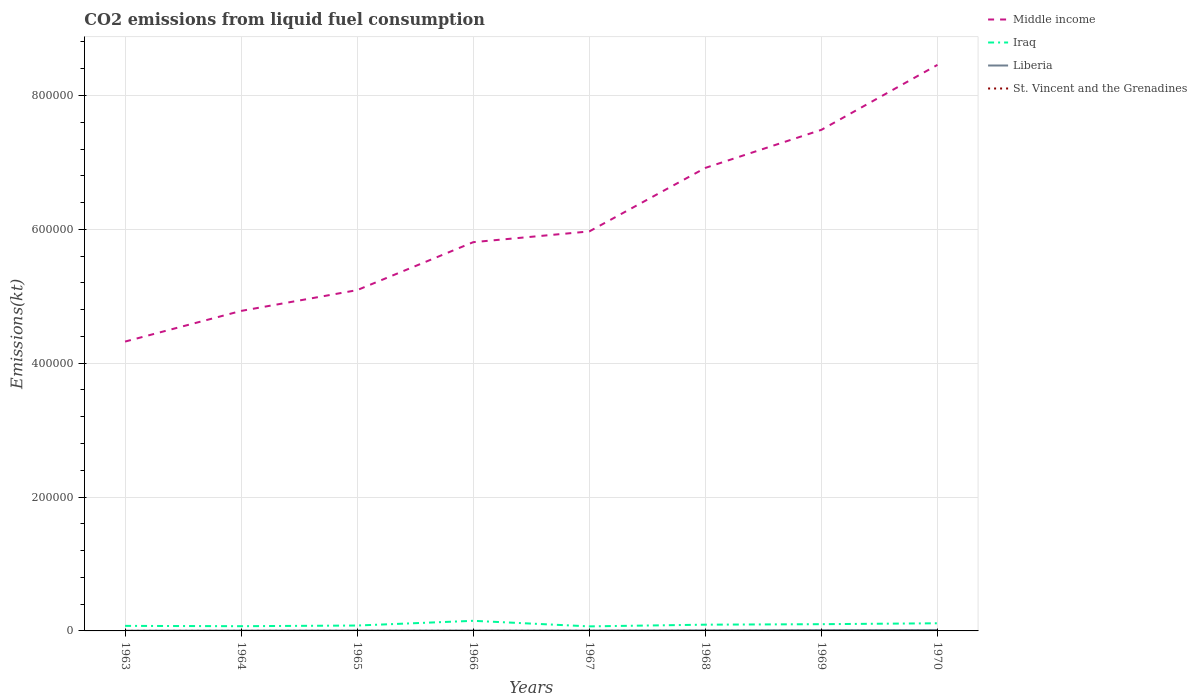Does the line corresponding to Liberia intersect with the line corresponding to St. Vincent and the Grenadines?
Provide a short and direct response. No. Is the number of lines equal to the number of legend labels?
Your answer should be very brief. Yes. Across all years, what is the maximum amount of CO2 emitted in Middle income?
Provide a succinct answer. 4.32e+05. In which year was the amount of CO2 emitted in St. Vincent and the Grenadines maximum?
Your answer should be very brief. 1963. What is the total amount of CO2 emitted in Liberia in the graph?
Provide a short and direct response. -245.69. What is the difference between the highest and the second highest amount of CO2 emitted in Liberia?
Offer a terse response. 1052.43. What is the difference between the highest and the lowest amount of CO2 emitted in St. Vincent and the Grenadines?
Your response must be concise. 3. Is the amount of CO2 emitted in St. Vincent and the Grenadines strictly greater than the amount of CO2 emitted in Middle income over the years?
Offer a terse response. Yes. How many years are there in the graph?
Offer a terse response. 8. What is the difference between two consecutive major ticks on the Y-axis?
Your answer should be very brief. 2.00e+05. Does the graph contain any zero values?
Provide a short and direct response. No. Does the graph contain grids?
Your response must be concise. Yes. Where does the legend appear in the graph?
Make the answer very short. Top right. How are the legend labels stacked?
Offer a terse response. Vertical. What is the title of the graph?
Make the answer very short. CO2 emissions from liquid fuel consumption. What is the label or title of the X-axis?
Your answer should be very brief. Years. What is the label or title of the Y-axis?
Keep it short and to the point. Emissions(kt). What is the Emissions(kt) of Middle income in 1963?
Make the answer very short. 4.32e+05. What is the Emissions(kt) in Iraq in 1963?
Provide a short and direct response. 7528.35. What is the Emissions(kt) in Liberia in 1963?
Offer a terse response. 355.7. What is the Emissions(kt) of St. Vincent and the Grenadines in 1963?
Ensure brevity in your answer.  14.67. What is the Emissions(kt) in Middle income in 1964?
Provide a succinct answer. 4.78e+05. What is the Emissions(kt) in Iraq in 1964?
Offer a very short reply. 7066.31. What is the Emissions(kt) of Liberia in 1964?
Keep it short and to the point. 484.04. What is the Emissions(kt) of St. Vincent and the Grenadines in 1964?
Offer a terse response. 18.34. What is the Emissions(kt) in Middle income in 1965?
Offer a terse response. 5.09e+05. What is the Emissions(kt) in Iraq in 1965?
Give a very brief answer. 8052.73. What is the Emissions(kt) in Liberia in 1965?
Ensure brevity in your answer.  557.38. What is the Emissions(kt) in St. Vincent and the Grenadines in 1965?
Your answer should be very brief. 14.67. What is the Emissions(kt) of Middle income in 1966?
Your response must be concise. 5.81e+05. What is the Emissions(kt) of Iraq in 1966?
Ensure brevity in your answer.  1.51e+04. What is the Emissions(kt) in Liberia in 1966?
Your response must be concise. 612.39. What is the Emissions(kt) in St. Vincent and the Grenadines in 1966?
Provide a short and direct response. 18.34. What is the Emissions(kt) of Middle income in 1967?
Provide a succinct answer. 5.97e+05. What is the Emissions(kt) of Iraq in 1967?
Offer a terse response. 6787.62. What is the Emissions(kt) in Liberia in 1967?
Give a very brief answer. 612.39. What is the Emissions(kt) of St. Vincent and the Grenadines in 1967?
Your answer should be compact. 18.34. What is the Emissions(kt) in Middle income in 1968?
Give a very brief answer. 6.92e+05. What is the Emissions(kt) in Iraq in 1968?
Provide a succinct answer. 9343.52. What is the Emissions(kt) of Liberia in 1968?
Offer a terse response. 858.08. What is the Emissions(kt) in St. Vincent and the Grenadines in 1968?
Your response must be concise. 22. What is the Emissions(kt) of Middle income in 1969?
Keep it short and to the point. 7.49e+05. What is the Emissions(kt) of Iraq in 1969?
Ensure brevity in your answer.  1.01e+04. What is the Emissions(kt) of Liberia in 1969?
Your answer should be very brief. 1235.78. What is the Emissions(kt) of St. Vincent and the Grenadines in 1969?
Make the answer very short. 29.34. What is the Emissions(kt) in Middle income in 1970?
Offer a very short reply. 8.46e+05. What is the Emissions(kt) in Iraq in 1970?
Offer a very short reply. 1.14e+04. What is the Emissions(kt) in Liberia in 1970?
Make the answer very short. 1408.13. What is the Emissions(kt) in St. Vincent and the Grenadines in 1970?
Your answer should be very brief. 29.34. Across all years, what is the maximum Emissions(kt) in Middle income?
Offer a terse response. 8.46e+05. Across all years, what is the maximum Emissions(kt) of Iraq?
Offer a terse response. 1.51e+04. Across all years, what is the maximum Emissions(kt) in Liberia?
Offer a terse response. 1408.13. Across all years, what is the maximum Emissions(kt) in St. Vincent and the Grenadines?
Make the answer very short. 29.34. Across all years, what is the minimum Emissions(kt) of Middle income?
Provide a succinct answer. 4.32e+05. Across all years, what is the minimum Emissions(kt) of Iraq?
Your answer should be very brief. 6787.62. Across all years, what is the minimum Emissions(kt) of Liberia?
Your answer should be very brief. 355.7. Across all years, what is the minimum Emissions(kt) in St. Vincent and the Grenadines?
Keep it short and to the point. 14.67. What is the total Emissions(kt) of Middle income in the graph?
Your answer should be compact. 4.88e+06. What is the total Emissions(kt) of Iraq in the graph?
Offer a terse response. 7.54e+04. What is the total Emissions(kt) of Liberia in the graph?
Offer a terse response. 6123.89. What is the total Emissions(kt) of St. Vincent and the Grenadines in the graph?
Offer a terse response. 165.01. What is the difference between the Emissions(kt) in Middle income in 1963 and that in 1964?
Your answer should be compact. -4.58e+04. What is the difference between the Emissions(kt) in Iraq in 1963 and that in 1964?
Give a very brief answer. 462.04. What is the difference between the Emissions(kt) in Liberia in 1963 and that in 1964?
Give a very brief answer. -128.34. What is the difference between the Emissions(kt) in St. Vincent and the Grenadines in 1963 and that in 1964?
Make the answer very short. -3.67. What is the difference between the Emissions(kt) in Middle income in 1963 and that in 1965?
Offer a very short reply. -7.69e+04. What is the difference between the Emissions(kt) in Iraq in 1963 and that in 1965?
Provide a short and direct response. -524.38. What is the difference between the Emissions(kt) in Liberia in 1963 and that in 1965?
Offer a very short reply. -201.69. What is the difference between the Emissions(kt) of Middle income in 1963 and that in 1966?
Ensure brevity in your answer.  -1.49e+05. What is the difference between the Emissions(kt) in Iraq in 1963 and that in 1966?
Keep it short and to the point. -7583.36. What is the difference between the Emissions(kt) of Liberia in 1963 and that in 1966?
Make the answer very short. -256.69. What is the difference between the Emissions(kt) in St. Vincent and the Grenadines in 1963 and that in 1966?
Give a very brief answer. -3.67. What is the difference between the Emissions(kt) in Middle income in 1963 and that in 1967?
Offer a very short reply. -1.65e+05. What is the difference between the Emissions(kt) of Iraq in 1963 and that in 1967?
Offer a very short reply. 740.73. What is the difference between the Emissions(kt) of Liberia in 1963 and that in 1967?
Make the answer very short. -256.69. What is the difference between the Emissions(kt) in St. Vincent and the Grenadines in 1963 and that in 1967?
Your answer should be very brief. -3.67. What is the difference between the Emissions(kt) in Middle income in 1963 and that in 1968?
Offer a very short reply. -2.59e+05. What is the difference between the Emissions(kt) in Iraq in 1963 and that in 1968?
Your answer should be very brief. -1815.16. What is the difference between the Emissions(kt) in Liberia in 1963 and that in 1968?
Ensure brevity in your answer.  -502.38. What is the difference between the Emissions(kt) of St. Vincent and the Grenadines in 1963 and that in 1968?
Keep it short and to the point. -7.33. What is the difference between the Emissions(kt) in Middle income in 1963 and that in 1969?
Provide a succinct answer. -3.16e+05. What is the difference between the Emissions(kt) of Iraq in 1963 and that in 1969?
Make the answer very short. -2548.57. What is the difference between the Emissions(kt) in Liberia in 1963 and that in 1969?
Keep it short and to the point. -880.08. What is the difference between the Emissions(kt) of St. Vincent and the Grenadines in 1963 and that in 1969?
Provide a succinct answer. -14.67. What is the difference between the Emissions(kt) of Middle income in 1963 and that in 1970?
Provide a short and direct response. -4.13e+05. What is the difference between the Emissions(kt) in Iraq in 1963 and that in 1970?
Your answer should be compact. -3898.02. What is the difference between the Emissions(kt) in Liberia in 1963 and that in 1970?
Your answer should be compact. -1052.43. What is the difference between the Emissions(kt) of St. Vincent and the Grenadines in 1963 and that in 1970?
Make the answer very short. -14.67. What is the difference between the Emissions(kt) in Middle income in 1964 and that in 1965?
Make the answer very short. -3.11e+04. What is the difference between the Emissions(kt) in Iraq in 1964 and that in 1965?
Make the answer very short. -986.42. What is the difference between the Emissions(kt) of Liberia in 1964 and that in 1965?
Offer a very short reply. -73.34. What is the difference between the Emissions(kt) in St. Vincent and the Grenadines in 1964 and that in 1965?
Your answer should be very brief. 3.67. What is the difference between the Emissions(kt) of Middle income in 1964 and that in 1966?
Offer a terse response. -1.03e+05. What is the difference between the Emissions(kt) in Iraq in 1964 and that in 1966?
Keep it short and to the point. -8045.4. What is the difference between the Emissions(kt) of Liberia in 1964 and that in 1966?
Your answer should be very brief. -128.34. What is the difference between the Emissions(kt) in Middle income in 1964 and that in 1967?
Your answer should be very brief. -1.19e+05. What is the difference between the Emissions(kt) of Iraq in 1964 and that in 1967?
Keep it short and to the point. 278.69. What is the difference between the Emissions(kt) of Liberia in 1964 and that in 1967?
Make the answer very short. -128.34. What is the difference between the Emissions(kt) of Middle income in 1964 and that in 1968?
Provide a succinct answer. -2.14e+05. What is the difference between the Emissions(kt) of Iraq in 1964 and that in 1968?
Give a very brief answer. -2277.21. What is the difference between the Emissions(kt) in Liberia in 1964 and that in 1968?
Your answer should be compact. -374.03. What is the difference between the Emissions(kt) of St. Vincent and the Grenadines in 1964 and that in 1968?
Offer a terse response. -3.67. What is the difference between the Emissions(kt) of Middle income in 1964 and that in 1969?
Offer a very short reply. -2.71e+05. What is the difference between the Emissions(kt) of Iraq in 1964 and that in 1969?
Ensure brevity in your answer.  -3010.61. What is the difference between the Emissions(kt) in Liberia in 1964 and that in 1969?
Offer a terse response. -751.74. What is the difference between the Emissions(kt) in St. Vincent and the Grenadines in 1964 and that in 1969?
Keep it short and to the point. -11. What is the difference between the Emissions(kt) in Middle income in 1964 and that in 1970?
Provide a short and direct response. -3.68e+05. What is the difference between the Emissions(kt) in Iraq in 1964 and that in 1970?
Provide a succinct answer. -4360.06. What is the difference between the Emissions(kt) in Liberia in 1964 and that in 1970?
Keep it short and to the point. -924.08. What is the difference between the Emissions(kt) of St. Vincent and the Grenadines in 1964 and that in 1970?
Your answer should be very brief. -11. What is the difference between the Emissions(kt) in Middle income in 1965 and that in 1966?
Offer a terse response. -7.16e+04. What is the difference between the Emissions(kt) of Iraq in 1965 and that in 1966?
Offer a very short reply. -7058.98. What is the difference between the Emissions(kt) of Liberia in 1965 and that in 1966?
Your response must be concise. -55.01. What is the difference between the Emissions(kt) of St. Vincent and the Grenadines in 1965 and that in 1966?
Make the answer very short. -3.67. What is the difference between the Emissions(kt) of Middle income in 1965 and that in 1967?
Offer a very short reply. -8.77e+04. What is the difference between the Emissions(kt) in Iraq in 1965 and that in 1967?
Keep it short and to the point. 1265.12. What is the difference between the Emissions(kt) in Liberia in 1965 and that in 1967?
Ensure brevity in your answer.  -55.01. What is the difference between the Emissions(kt) in St. Vincent and the Grenadines in 1965 and that in 1967?
Give a very brief answer. -3.67. What is the difference between the Emissions(kt) in Middle income in 1965 and that in 1968?
Give a very brief answer. -1.83e+05. What is the difference between the Emissions(kt) in Iraq in 1965 and that in 1968?
Provide a succinct answer. -1290.78. What is the difference between the Emissions(kt) in Liberia in 1965 and that in 1968?
Keep it short and to the point. -300.69. What is the difference between the Emissions(kt) in St. Vincent and the Grenadines in 1965 and that in 1968?
Ensure brevity in your answer.  -7.33. What is the difference between the Emissions(kt) of Middle income in 1965 and that in 1969?
Your answer should be very brief. -2.39e+05. What is the difference between the Emissions(kt) in Iraq in 1965 and that in 1969?
Offer a terse response. -2024.18. What is the difference between the Emissions(kt) in Liberia in 1965 and that in 1969?
Give a very brief answer. -678.39. What is the difference between the Emissions(kt) of St. Vincent and the Grenadines in 1965 and that in 1969?
Your answer should be compact. -14.67. What is the difference between the Emissions(kt) in Middle income in 1965 and that in 1970?
Offer a very short reply. -3.37e+05. What is the difference between the Emissions(kt) of Iraq in 1965 and that in 1970?
Provide a short and direct response. -3373.64. What is the difference between the Emissions(kt) in Liberia in 1965 and that in 1970?
Your response must be concise. -850.74. What is the difference between the Emissions(kt) in St. Vincent and the Grenadines in 1965 and that in 1970?
Provide a short and direct response. -14.67. What is the difference between the Emissions(kt) of Middle income in 1966 and that in 1967?
Provide a short and direct response. -1.61e+04. What is the difference between the Emissions(kt) in Iraq in 1966 and that in 1967?
Your answer should be very brief. 8324.09. What is the difference between the Emissions(kt) in Liberia in 1966 and that in 1967?
Your answer should be very brief. 0. What is the difference between the Emissions(kt) in St. Vincent and the Grenadines in 1966 and that in 1967?
Your answer should be compact. 0. What is the difference between the Emissions(kt) of Middle income in 1966 and that in 1968?
Offer a very short reply. -1.11e+05. What is the difference between the Emissions(kt) in Iraq in 1966 and that in 1968?
Provide a short and direct response. 5768.19. What is the difference between the Emissions(kt) of Liberia in 1966 and that in 1968?
Offer a terse response. -245.69. What is the difference between the Emissions(kt) of St. Vincent and the Grenadines in 1966 and that in 1968?
Your answer should be very brief. -3.67. What is the difference between the Emissions(kt) in Middle income in 1966 and that in 1969?
Your response must be concise. -1.68e+05. What is the difference between the Emissions(kt) in Iraq in 1966 and that in 1969?
Make the answer very short. 5034.79. What is the difference between the Emissions(kt) of Liberia in 1966 and that in 1969?
Keep it short and to the point. -623.39. What is the difference between the Emissions(kt) of St. Vincent and the Grenadines in 1966 and that in 1969?
Make the answer very short. -11. What is the difference between the Emissions(kt) in Middle income in 1966 and that in 1970?
Offer a terse response. -2.65e+05. What is the difference between the Emissions(kt) in Iraq in 1966 and that in 1970?
Keep it short and to the point. 3685.34. What is the difference between the Emissions(kt) in Liberia in 1966 and that in 1970?
Make the answer very short. -795.74. What is the difference between the Emissions(kt) in St. Vincent and the Grenadines in 1966 and that in 1970?
Make the answer very short. -11. What is the difference between the Emissions(kt) in Middle income in 1967 and that in 1968?
Your answer should be compact. -9.49e+04. What is the difference between the Emissions(kt) in Iraq in 1967 and that in 1968?
Provide a succinct answer. -2555.9. What is the difference between the Emissions(kt) in Liberia in 1967 and that in 1968?
Your answer should be compact. -245.69. What is the difference between the Emissions(kt) in St. Vincent and the Grenadines in 1967 and that in 1968?
Ensure brevity in your answer.  -3.67. What is the difference between the Emissions(kt) of Middle income in 1967 and that in 1969?
Offer a very short reply. -1.52e+05. What is the difference between the Emissions(kt) in Iraq in 1967 and that in 1969?
Provide a succinct answer. -3289.3. What is the difference between the Emissions(kt) in Liberia in 1967 and that in 1969?
Offer a terse response. -623.39. What is the difference between the Emissions(kt) in St. Vincent and the Grenadines in 1967 and that in 1969?
Offer a terse response. -11. What is the difference between the Emissions(kt) of Middle income in 1967 and that in 1970?
Your answer should be very brief. -2.49e+05. What is the difference between the Emissions(kt) of Iraq in 1967 and that in 1970?
Offer a very short reply. -4638.76. What is the difference between the Emissions(kt) of Liberia in 1967 and that in 1970?
Your answer should be very brief. -795.74. What is the difference between the Emissions(kt) of St. Vincent and the Grenadines in 1967 and that in 1970?
Ensure brevity in your answer.  -11. What is the difference between the Emissions(kt) of Middle income in 1968 and that in 1969?
Your answer should be very brief. -5.69e+04. What is the difference between the Emissions(kt) in Iraq in 1968 and that in 1969?
Offer a very short reply. -733.4. What is the difference between the Emissions(kt) of Liberia in 1968 and that in 1969?
Provide a short and direct response. -377.7. What is the difference between the Emissions(kt) of St. Vincent and the Grenadines in 1968 and that in 1969?
Give a very brief answer. -7.33. What is the difference between the Emissions(kt) of Middle income in 1968 and that in 1970?
Offer a very short reply. -1.54e+05. What is the difference between the Emissions(kt) in Iraq in 1968 and that in 1970?
Your answer should be very brief. -2082.86. What is the difference between the Emissions(kt) in Liberia in 1968 and that in 1970?
Provide a short and direct response. -550.05. What is the difference between the Emissions(kt) in St. Vincent and the Grenadines in 1968 and that in 1970?
Give a very brief answer. -7.33. What is the difference between the Emissions(kt) in Middle income in 1969 and that in 1970?
Make the answer very short. -9.70e+04. What is the difference between the Emissions(kt) of Iraq in 1969 and that in 1970?
Keep it short and to the point. -1349.46. What is the difference between the Emissions(kt) of Liberia in 1969 and that in 1970?
Provide a succinct answer. -172.35. What is the difference between the Emissions(kt) of St. Vincent and the Grenadines in 1969 and that in 1970?
Offer a terse response. 0. What is the difference between the Emissions(kt) in Middle income in 1963 and the Emissions(kt) in Iraq in 1964?
Offer a very short reply. 4.25e+05. What is the difference between the Emissions(kt) of Middle income in 1963 and the Emissions(kt) of Liberia in 1964?
Your response must be concise. 4.32e+05. What is the difference between the Emissions(kt) in Middle income in 1963 and the Emissions(kt) in St. Vincent and the Grenadines in 1964?
Your answer should be compact. 4.32e+05. What is the difference between the Emissions(kt) in Iraq in 1963 and the Emissions(kt) in Liberia in 1964?
Your response must be concise. 7044.31. What is the difference between the Emissions(kt) in Iraq in 1963 and the Emissions(kt) in St. Vincent and the Grenadines in 1964?
Make the answer very short. 7510.02. What is the difference between the Emissions(kt) of Liberia in 1963 and the Emissions(kt) of St. Vincent and the Grenadines in 1964?
Give a very brief answer. 337.36. What is the difference between the Emissions(kt) in Middle income in 1963 and the Emissions(kt) in Iraq in 1965?
Provide a short and direct response. 4.24e+05. What is the difference between the Emissions(kt) of Middle income in 1963 and the Emissions(kt) of Liberia in 1965?
Your answer should be compact. 4.32e+05. What is the difference between the Emissions(kt) in Middle income in 1963 and the Emissions(kt) in St. Vincent and the Grenadines in 1965?
Provide a succinct answer. 4.32e+05. What is the difference between the Emissions(kt) in Iraq in 1963 and the Emissions(kt) in Liberia in 1965?
Ensure brevity in your answer.  6970.97. What is the difference between the Emissions(kt) in Iraq in 1963 and the Emissions(kt) in St. Vincent and the Grenadines in 1965?
Ensure brevity in your answer.  7513.68. What is the difference between the Emissions(kt) in Liberia in 1963 and the Emissions(kt) in St. Vincent and the Grenadines in 1965?
Keep it short and to the point. 341.03. What is the difference between the Emissions(kt) of Middle income in 1963 and the Emissions(kt) of Iraq in 1966?
Provide a succinct answer. 4.17e+05. What is the difference between the Emissions(kt) of Middle income in 1963 and the Emissions(kt) of Liberia in 1966?
Provide a succinct answer. 4.32e+05. What is the difference between the Emissions(kt) in Middle income in 1963 and the Emissions(kt) in St. Vincent and the Grenadines in 1966?
Your answer should be compact. 4.32e+05. What is the difference between the Emissions(kt) of Iraq in 1963 and the Emissions(kt) of Liberia in 1966?
Keep it short and to the point. 6915.96. What is the difference between the Emissions(kt) in Iraq in 1963 and the Emissions(kt) in St. Vincent and the Grenadines in 1966?
Your answer should be very brief. 7510.02. What is the difference between the Emissions(kt) in Liberia in 1963 and the Emissions(kt) in St. Vincent and the Grenadines in 1966?
Your answer should be very brief. 337.36. What is the difference between the Emissions(kt) in Middle income in 1963 and the Emissions(kt) in Iraq in 1967?
Offer a very short reply. 4.26e+05. What is the difference between the Emissions(kt) of Middle income in 1963 and the Emissions(kt) of Liberia in 1967?
Your response must be concise. 4.32e+05. What is the difference between the Emissions(kt) in Middle income in 1963 and the Emissions(kt) in St. Vincent and the Grenadines in 1967?
Keep it short and to the point. 4.32e+05. What is the difference between the Emissions(kt) in Iraq in 1963 and the Emissions(kt) in Liberia in 1967?
Offer a very short reply. 6915.96. What is the difference between the Emissions(kt) of Iraq in 1963 and the Emissions(kt) of St. Vincent and the Grenadines in 1967?
Offer a very short reply. 7510.02. What is the difference between the Emissions(kt) of Liberia in 1963 and the Emissions(kt) of St. Vincent and the Grenadines in 1967?
Provide a short and direct response. 337.36. What is the difference between the Emissions(kt) of Middle income in 1963 and the Emissions(kt) of Iraq in 1968?
Provide a short and direct response. 4.23e+05. What is the difference between the Emissions(kt) of Middle income in 1963 and the Emissions(kt) of Liberia in 1968?
Make the answer very short. 4.31e+05. What is the difference between the Emissions(kt) of Middle income in 1963 and the Emissions(kt) of St. Vincent and the Grenadines in 1968?
Give a very brief answer. 4.32e+05. What is the difference between the Emissions(kt) in Iraq in 1963 and the Emissions(kt) in Liberia in 1968?
Provide a succinct answer. 6670.27. What is the difference between the Emissions(kt) in Iraq in 1963 and the Emissions(kt) in St. Vincent and the Grenadines in 1968?
Keep it short and to the point. 7506.35. What is the difference between the Emissions(kt) of Liberia in 1963 and the Emissions(kt) of St. Vincent and the Grenadines in 1968?
Give a very brief answer. 333.7. What is the difference between the Emissions(kt) of Middle income in 1963 and the Emissions(kt) of Iraq in 1969?
Your response must be concise. 4.22e+05. What is the difference between the Emissions(kt) in Middle income in 1963 and the Emissions(kt) in Liberia in 1969?
Offer a very short reply. 4.31e+05. What is the difference between the Emissions(kt) of Middle income in 1963 and the Emissions(kt) of St. Vincent and the Grenadines in 1969?
Offer a terse response. 4.32e+05. What is the difference between the Emissions(kt) in Iraq in 1963 and the Emissions(kt) in Liberia in 1969?
Provide a succinct answer. 6292.57. What is the difference between the Emissions(kt) of Iraq in 1963 and the Emissions(kt) of St. Vincent and the Grenadines in 1969?
Your answer should be very brief. 7499.02. What is the difference between the Emissions(kt) in Liberia in 1963 and the Emissions(kt) in St. Vincent and the Grenadines in 1969?
Give a very brief answer. 326.36. What is the difference between the Emissions(kt) of Middle income in 1963 and the Emissions(kt) of Iraq in 1970?
Provide a short and direct response. 4.21e+05. What is the difference between the Emissions(kt) in Middle income in 1963 and the Emissions(kt) in Liberia in 1970?
Offer a very short reply. 4.31e+05. What is the difference between the Emissions(kt) in Middle income in 1963 and the Emissions(kt) in St. Vincent and the Grenadines in 1970?
Your answer should be very brief. 4.32e+05. What is the difference between the Emissions(kt) of Iraq in 1963 and the Emissions(kt) of Liberia in 1970?
Keep it short and to the point. 6120.22. What is the difference between the Emissions(kt) in Iraq in 1963 and the Emissions(kt) in St. Vincent and the Grenadines in 1970?
Offer a terse response. 7499.02. What is the difference between the Emissions(kt) in Liberia in 1963 and the Emissions(kt) in St. Vincent and the Grenadines in 1970?
Your answer should be very brief. 326.36. What is the difference between the Emissions(kt) in Middle income in 1964 and the Emissions(kt) in Iraq in 1965?
Give a very brief answer. 4.70e+05. What is the difference between the Emissions(kt) of Middle income in 1964 and the Emissions(kt) of Liberia in 1965?
Provide a short and direct response. 4.78e+05. What is the difference between the Emissions(kt) of Middle income in 1964 and the Emissions(kt) of St. Vincent and the Grenadines in 1965?
Offer a very short reply. 4.78e+05. What is the difference between the Emissions(kt) of Iraq in 1964 and the Emissions(kt) of Liberia in 1965?
Your answer should be compact. 6508.93. What is the difference between the Emissions(kt) of Iraq in 1964 and the Emissions(kt) of St. Vincent and the Grenadines in 1965?
Your response must be concise. 7051.64. What is the difference between the Emissions(kt) in Liberia in 1964 and the Emissions(kt) in St. Vincent and the Grenadines in 1965?
Offer a very short reply. 469.38. What is the difference between the Emissions(kt) of Middle income in 1964 and the Emissions(kt) of Iraq in 1966?
Provide a succinct answer. 4.63e+05. What is the difference between the Emissions(kt) in Middle income in 1964 and the Emissions(kt) in Liberia in 1966?
Make the answer very short. 4.77e+05. What is the difference between the Emissions(kt) of Middle income in 1964 and the Emissions(kt) of St. Vincent and the Grenadines in 1966?
Your response must be concise. 4.78e+05. What is the difference between the Emissions(kt) of Iraq in 1964 and the Emissions(kt) of Liberia in 1966?
Give a very brief answer. 6453.92. What is the difference between the Emissions(kt) of Iraq in 1964 and the Emissions(kt) of St. Vincent and the Grenadines in 1966?
Your answer should be very brief. 7047.97. What is the difference between the Emissions(kt) in Liberia in 1964 and the Emissions(kt) in St. Vincent and the Grenadines in 1966?
Keep it short and to the point. 465.71. What is the difference between the Emissions(kt) of Middle income in 1964 and the Emissions(kt) of Iraq in 1967?
Provide a short and direct response. 4.71e+05. What is the difference between the Emissions(kt) in Middle income in 1964 and the Emissions(kt) in Liberia in 1967?
Offer a terse response. 4.77e+05. What is the difference between the Emissions(kt) in Middle income in 1964 and the Emissions(kt) in St. Vincent and the Grenadines in 1967?
Give a very brief answer. 4.78e+05. What is the difference between the Emissions(kt) of Iraq in 1964 and the Emissions(kt) of Liberia in 1967?
Your answer should be very brief. 6453.92. What is the difference between the Emissions(kt) in Iraq in 1964 and the Emissions(kt) in St. Vincent and the Grenadines in 1967?
Your answer should be very brief. 7047.97. What is the difference between the Emissions(kt) of Liberia in 1964 and the Emissions(kt) of St. Vincent and the Grenadines in 1967?
Your response must be concise. 465.71. What is the difference between the Emissions(kt) of Middle income in 1964 and the Emissions(kt) of Iraq in 1968?
Make the answer very short. 4.69e+05. What is the difference between the Emissions(kt) of Middle income in 1964 and the Emissions(kt) of Liberia in 1968?
Keep it short and to the point. 4.77e+05. What is the difference between the Emissions(kt) of Middle income in 1964 and the Emissions(kt) of St. Vincent and the Grenadines in 1968?
Provide a short and direct response. 4.78e+05. What is the difference between the Emissions(kt) in Iraq in 1964 and the Emissions(kt) in Liberia in 1968?
Your answer should be compact. 6208.23. What is the difference between the Emissions(kt) of Iraq in 1964 and the Emissions(kt) of St. Vincent and the Grenadines in 1968?
Keep it short and to the point. 7044.31. What is the difference between the Emissions(kt) of Liberia in 1964 and the Emissions(kt) of St. Vincent and the Grenadines in 1968?
Offer a terse response. 462.04. What is the difference between the Emissions(kt) of Middle income in 1964 and the Emissions(kt) of Iraq in 1969?
Give a very brief answer. 4.68e+05. What is the difference between the Emissions(kt) in Middle income in 1964 and the Emissions(kt) in Liberia in 1969?
Your answer should be very brief. 4.77e+05. What is the difference between the Emissions(kt) of Middle income in 1964 and the Emissions(kt) of St. Vincent and the Grenadines in 1969?
Give a very brief answer. 4.78e+05. What is the difference between the Emissions(kt) in Iraq in 1964 and the Emissions(kt) in Liberia in 1969?
Offer a terse response. 5830.53. What is the difference between the Emissions(kt) of Iraq in 1964 and the Emissions(kt) of St. Vincent and the Grenadines in 1969?
Keep it short and to the point. 7036.97. What is the difference between the Emissions(kt) of Liberia in 1964 and the Emissions(kt) of St. Vincent and the Grenadines in 1969?
Your answer should be very brief. 454.71. What is the difference between the Emissions(kt) in Middle income in 1964 and the Emissions(kt) in Iraq in 1970?
Provide a short and direct response. 4.67e+05. What is the difference between the Emissions(kt) of Middle income in 1964 and the Emissions(kt) of Liberia in 1970?
Your answer should be compact. 4.77e+05. What is the difference between the Emissions(kt) of Middle income in 1964 and the Emissions(kt) of St. Vincent and the Grenadines in 1970?
Give a very brief answer. 4.78e+05. What is the difference between the Emissions(kt) of Iraq in 1964 and the Emissions(kt) of Liberia in 1970?
Your answer should be compact. 5658.18. What is the difference between the Emissions(kt) of Iraq in 1964 and the Emissions(kt) of St. Vincent and the Grenadines in 1970?
Make the answer very short. 7036.97. What is the difference between the Emissions(kt) in Liberia in 1964 and the Emissions(kt) in St. Vincent and the Grenadines in 1970?
Ensure brevity in your answer.  454.71. What is the difference between the Emissions(kt) in Middle income in 1965 and the Emissions(kt) in Iraq in 1966?
Offer a very short reply. 4.94e+05. What is the difference between the Emissions(kt) in Middle income in 1965 and the Emissions(kt) in Liberia in 1966?
Give a very brief answer. 5.09e+05. What is the difference between the Emissions(kt) in Middle income in 1965 and the Emissions(kt) in St. Vincent and the Grenadines in 1966?
Keep it short and to the point. 5.09e+05. What is the difference between the Emissions(kt) of Iraq in 1965 and the Emissions(kt) of Liberia in 1966?
Keep it short and to the point. 7440.34. What is the difference between the Emissions(kt) of Iraq in 1965 and the Emissions(kt) of St. Vincent and the Grenadines in 1966?
Keep it short and to the point. 8034.4. What is the difference between the Emissions(kt) in Liberia in 1965 and the Emissions(kt) in St. Vincent and the Grenadines in 1966?
Your answer should be compact. 539.05. What is the difference between the Emissions(kt) of Middle income in 1965 and the Emissions(kt) of Iraq in 1967?
Your answer should be very brief. 5.02e+05. What is the difference between the Emissions(kt) of Middle income in 1965 and the Emissions(kt) of Liberia in 1967?
Ensure brevity in your answer.  5.09e+05. What is the difference between the Emissions(kt) in Middle income in 1965 and the Emissions(kt) in St. Vincent and the Grenadines in 1967?
Make the answer very short. 5.09e+05. What is the difference between the Emissions(kt) in Iraq in 1965 and the Emissions(kt) in Liberia in 1967?
Make the answer very short. 7440.34. What is the difference between the Emissions(kt) in Iraq in 1965 and the Emissions(kt) in St. Vincent and the Grenadines in 1967?
Offer a terse response. 8034.4. What is the difference between the Emissions(kt) of Liberia in 1965 and the Emissions(kt) of St. Vincent and the Grenadines in 1967?
Your answer should be compact. 539.05. What is the difference between the Emissions(kt) in Middle income in 1965 and the Emissions(kt) in Iraq in 1968?
Keep it short and to the point. 5.00e+05. What is the difference between the Emissions(kt) of Middle income in 1965 and the Emissions(kt) of Liberia in 1968?
Provide a succinct answer. 5.08e+05. What is the difference between the Emissions(kt) in Middle income in 1965 and the Emissions(kt) in St. Vincent and the Grenadines in 1968?
Keep it short and to the point. 5.09e+05. What is the difference between the Emissions(kt) in Iraq in 1965 and the Emissions(kt) in Liberia in 1968?
Give a very brief answer. 7194.65. What is the difference between the Emissions(kt) of Iraq in 1965 and the Emissions(kt) of St. Vincent and the Grenadines in 1968?
Your answer should be compact. 8030.73. What is the difference between the Emissions(kt) of Liberia in 1965 and the Emissions(kt) of St. Vincent and the Grenadines in 1968?
Make the answer very short. 535.38. What is the difference between the Emissions(kt) in Middle income in 1965 and the Emissions(kt) in Iraq in 1969?
Your answer should be very brief. 4.99e+05. What is the difference between the Emissions(kt) in Middle income in 1965 and the Emissions(kt) in Liberia in 1969?
Offer a terse response. 5.08e+05. What is the difference between the Emissions(kt) in Middle income in 1965 and the Emissions(kt) in St. Vincent and the Grenadines in 1969?
Give a very brief answer. 5.09e+05. What is the difference between the Emissions(kt) in Iraq in 1965 and the Emissions(kt) in Liberia in 1969?
Provide a short and direct response. 6816.95. What is the difference between the Emissions(kt) of Iraq in 1965 and the Emissions(kt) of St. Vincent and the Grenadines in 1969?
Provide a succinct answer. 8023.4. What is the difference between the Emissions(kt) of Liberia in 1965 and the Emissions(kt) of St. Vincent and the Grenadines in 1969?
Offer a very short reply. 528.05. What is the difference between the Emissions(kt) of Middle income in 1965 and the Emissions(kt) of Iraq in 1970?
Offer a very short reply. 4.98e+05. What is the difference between the Emissions(kt) in Middle income in 1965 and the Emissions(kt) in Liberia in 1970?
Your response must be concise. 5.08e+05. What is the difference between the Emissions(kt) in Middle income in 1965 and the Emissions(kt) in St. Vincent and the Grenadines in 1970?
Your answer should be very brief. 5.09e+05. What is the difference between the Emissions(kt) of Iraq in 1965 and the Emissions(kt) of Liberia in 1970?
Offer a very short reply. 6644.6. What is the difference between the Emissions(kt) in Iraq in 1965 and the Emissions(kt) in St. Vincent and the Grenadines in 1970?
Your response must be concise. 8023.4. What is the difference between the Emissions(kt) in Liberia in 1965 and the Emissions(kt) in St. Vincent and the Grenadines in 1970?
Your answer should be compact. 528.05. What is the difference between the Emissions(kt) in Middle income in 1966 and the Emissions(kt) in Iraq in 1967?
Make the answer very short. 5.74e+05. What is the difference between the Emissions(kt) of Middle income in 1966 and the Emissions(kt) of Liberia in 1967?
Your answer should be very brief. 5.80e+05. What is the difference between the Emissions(kt) of Middle income in 1966 and the Emissions(kt) of St. Vincent and the Grenadines in 1967?
Provide a short and direct response. 5.81e+05. What is the difference between the Emissions(kt) in Iraq in 1966 and the Emissions(kt) in Liberia in 1967?
Your answer should be compact. 1.45e+04. What is the difference between the Emissions(kt) of Iraq in 1966 and the Emissions(kt) of St. Vincent and the Grenadines in 1967?
Provide a short and direct response. 1.51e+04. What is the difference between the Emissions(kt) of Liberia in 1966 and the Emissions(kt) of St. Vincent and the Grenadines in 1967?
Your answer should be very brief. 594.05. What is the difference between the Emissions(kt) in Middle income in 1966 and the Emissions(kt) in Iraq in 1968?
Your answer should be compact. 5.71e+05. What is the difference between the Emissions(kt) in Middle income in 1966 and the Emissions(kt) in Liberia in 1968?
Keep it short and to the point. 5.80e+05. What is the difference between the Emissions(kt) of Middle income in 1966 and the Emissions(kt) of St. Vincent and the Grenadines in 1968?
Ensure brevity in your answer.  5.81e+05. What is the difference between the Emissions(kt) in Iraq in 1966 and the Emissions(kt) in Liberia in 1968?
Provide a short and direct response. 1.43e+04. What is the difference between the Emissions(kt) of Iraq in 1966 and the Emissions(kt) of St. Vincent and the Grenadines in 1968?
Keep it short and to the point. 1.51e+04. What is the difference between the Emissions(kt) of Liberia in 1966 and the Emissions(kt) of St. Vincent and the Grenadines in 1968?
Keep it short and to the point. 590.39. What is the difference between the Emissions(kt) in Middle income in 1966 and the Emissions(kt) in Iraq in 1969?
Provide a succinct answer. 5.71e+05. What is the difference between the Emissions(kt) in Middle income in 1966 and the Emissions(kt) in Liberia in 1969?
Provide a short and direct response. 5.80e+05. What is the difference between the Emissions(kt) of Middle income in 1966 and the Emissions(kt) of St. Vincent and the Grenadines in 1969?
Provide a succinct answer. 5.81e+05. What is the difference between the Emissions(kt) of Iraq in 1966 and the Emissions(kt) of Liberia in 1969?
Ensure brevity in your answer.  1.39e+04. What is the difference between the Emissions(kt) in Iraq in 1966 and the Emissions(kt) in St. Vincent and the Grenadines in 1969?
Provide a short and direct response. 1.51e+04. What is the difference between the Emissions(kt) in Liberia in 1966 and the Emissions(kt) in St. Vincent and the Grenadines in 1969?
Ensure brevity in your answer.  583.05. What is the difference between the Emissions(kt) in Middle income in 1966 and the Emissions(kt) in Iraq in 1970?
Ensure brevity in your answer.  5.69e+05. What is the difference between the Emissions(kt) in Middle income in 1966 and the Emissions(kt) in Liberia in 1970?
Offer a very short reply. 5.79e+05. What is the difference between the Emissions(kt) of Middle income in 1966 and the Emissions(kt) of St. Vincent and the Grenadines in 1970?
Your answer should be compact. 5.81e+05. What is the difference between the Emissions(kt) in Iraq in 1966 and the Emissions(kt) in Liberia in 1970?
Your answer should be compact. 1.37e+04. What is the difference between the Emissions(kt) in Iraq in 1966 and the Emissions(kt) in St. Vincent and the Grenadines in 1970?
Ensure brevity in your answer.  1.51e+04. What is the difference between the Emissions(kt) in Liberia in 1966 and the Emissions(kt) in St. Vincent and the Grenadines in 1970?
Your response must be concise. 583.05. What is the difference between the Emissions(kt) of Middle income in 1967 and the Emissions(kt) of Iraq in 1968?
Provide a short and direct response. 5.88e+05. What is the difference between the Emissions(kt) in Middle income in 1967 and the Emissions(kt) in Liberia in 1968?
Ensure brevity in your answer.  5.96e+05. What is the difference between the Emissions(kt) in Middle income in 1967 and the Emissions(kt) in St. Vincent and the Grenadines in 1968?
Provide a succinct answer. 5.97e+05. What is the difference between the Emissions(kt) of Iraq in 1967 and the Emissions(kt) of Liberia in 1968?
Provide a succinct answer. 5929.54. What is the difference between the Emissions(kt) of Iraq in 1967 and the Emissions(kt) of St. Vincent and the Grenadines in 1968?
Your answer should be compact. 6765.61. What is the difference between the Emissions(kt) of Liberia in 1967 and the Emissions(kt) of St. Vincent and the Grenadines in 1968?
Give a very brief answer. 590.39. What is the difference between the Emissions(kt) of Middle income in 1967 and the Emissions(kt) of Iraq in 1969?
Offer a terse response. 5.87e+05. What is the difference between the Emissions(kt) of Middle income in 1967 and the Emissions(kt) of Liberia in 1969?
Your answer should be very brief. 5.96e+05. What is the difference between the Emissions(kt) in Middle income in 1967 and the Emissions(kt) in St. Vincent and the Grenadines in 1969?
Offer a very short reply. 5.97e+05. What is the difference between the Emissions(kt) of Iraq in 1967 and the Emissions(kt) of Liberia in 1969?
Provide a short and direct response. 5551.84. What is the difference between the Emissions(kt) of Iraq in 1967 and the Emissions(kt) of St. Vincent and the Grenadines in 1969?
Your answer should be very brief. 6758.28. What is the difference between the Emissions(kt) of Liberia in 1967 and the Emissions(kt) of St. Vincent and the Grenadines in 1969?
Make the answer very short. 583.05. What is the difference between the Emissions(kt) in Middle income in 1967 and the Emissions(kt) in Iraq in 1970?
Ensure brevity in your answer.  5.85e+05. What is the difference between the Emissions(kt) in Middle income in 1967 and the Emissions(kt) in Liberia in 1970?
Offer a terse response. 5.95e+05. What is the difference between the Emissions(kt) of Middle income in 1967 and the Emissions(kt) of St. Vincent and the Grenadines in 1970?
Make the answer very short. 5.97e+05. What is the difference between the Emissions(kt) of Iraq in 1967 and the Emissions(kt) of Liberia in 1970?
Make the answer very short. 5379.49. What is the difference between the Emissions(kt) of Iraq in 1967 and the Emissions(kt) of St. Vincent and the Grenadines in 1970?
Give a very brief answer. 6758.28. What is the difference between the Emissions(kt) of Liberia in 1967 and the Emissions(kt) of St. Vincent and the Grenadines in 1970?
Ensure brevity in your answer.  583.05. What is the difference between the Emissions(kt) of Middle income in 1968 and the Emissions(kt) of Iraq in 1969?
Ensure brevity in your answer.  6.82e+05. What is the difference between the Emissions(kt) of Middle income in 1968 and the Emissions(kt) of Liberia in 1969?
Offer a very short reply. 6.91e+05. What is the difference between the Emissions(kt) of Middle income in 1968 and the Emissions(kt) of St. Vincent and the Grenadines in 1969?
Your response must be concise. 6.92e+05. What is the difference between the Emissions(kt) of Iraq in 1968 and the Emissions(kt) of Liberia in 1969?
Ensure brevity in your answer.  8107.74. What is the difference between the Emissions(kt) of Iraq in 1968 and the Emissions(kt) of St. Vincent and the Grenadines in 1969?
Ensure brevity in your answer.  9314.18. What is the difference between the Emissions(kt) in Liberia in 1968 and the Emissions(kt) in St. Vincent and the Grenadines in 1969?
Provide a succinct answer. 828.74. What is the difference between the Emissions(kt) in Middle income in 1968 and the Emissions(kt) in Iraq in 1970?
Provide a short and direct response. 6.80e+05. What is the difference between the Emissions(kt) in Middle income in 1968 and the Emissions(kt) in Liberia in 1970?
Provide a succinct answer. 6.90e+05. What is the difference between the Emissions(kt) in Middle income in 1968 and the Emissions(kt) in St. Vincent and the Grenadines in 1970?
Offer a terse response. 6.92e+05. What is the difference between the Emissions(kt) in Iraq in 1968 and the Emissions(kt) in Liberia in 1970?
Offer a very short reply. 7935.39. What is the difference between the Emissions(kt) of Iraq in 1968 and the Emissions(kt) of St. Vincent and the Grenadines in 1970?
Provide a short and direct response. 9314.18. What is the difference between the Emissions(kt) in Liberia in 1968 and the Emissions(kt) in St. Vincent and the Grenadines in 1970?
Give a very brief answer. 828.74. What is the difference between the Emissions(kt) in Middle income in 1969 and the Emissions(kt) in Iraq in 1970?
Give a very brief answer. 7.37e+05. What is the difference between the Emissions(kt) in Middle income in 1969 and the Emissions(kt) in Liberia in 1970?
Offer a terse response. 7.47e+05. What is the difference between the Emissions(kt) of Middle income in 1969 and the Emissions(kt) of St. Vincent and the Grenadines in 1970?
Ensure brevity in your answer.  7.49e+05. What is the difference between the Emissions(kt) in Iraq in 1969 and the Emissions(kt) in Liberia in 1970?
Your response must be concise. 8668.79. What is the difference between the Emissions(kt) in Iraq in 1969 and the Emissions(kt) in St. Vincent and the Grenadines in 1970?
Keep it short and to the point. 1.00e+04. What is the difference between the Emissions(kt) of Liberia in 1969 and the Emissions(kt) of St. Vincent and the Grenadines in 1970?
Offer a terse response. 1206.44. What is the average Emissions(kt) of Middle income per year?
Offer a very short reply. 6.10e+05. What is the average Emissions(kt) in Iraq per year?
Provide a short and direct response. 9424.19. What is the average Emissions(kt) in Liberia per year?
Offer a very short reply. 765.49. What is the average Emissions(kt) in St. Vincent and the Grenadines per year?
Provide a short and direct response. 20.63. In the year 1963, what is the difference between the Emissions(kt) of Middle income and Emissions(kt) of Iraq?
Offer a terse response. 4.25e+05. In the year 1963, what is the difference between the Emissions(kt) in Middle income and Emissions(kt) in Liberia?
Provide a succinct answer. 4.32e+05. In the year 1963, what is the difference between the Emissions(kt) in Middle income and Emissions(kt) in St. Vincent and the Grenadines?
Give a very brief answer. 4.32e+05. In the year 1963, what is the difference between the Emissions(kt) of Iraq and Emissions(kt) of Liberia?
Offer a very short reply. 7172.65. In the year 1963, what is the difference between the Emissions(kt) in Iraq and Emissions(kt) in St. Vincent and the Grenadines?
Provide a succinct answer. 7513.68. In the year 1963, what is the difference between the Emissions(kt) of Liberia and Emissions(kt) of St. Vincent and the Grenadines?
Offer a very short reply. 341.03. In the year 1964, what is the difference between the Emissions(kt) of Middle income and Emissions(kt) of Iraq?
Offer a very short reply. 4.71e+05. In the year 1964, what is the difference between the Emissions(kt) of Middle income and Emissions(kt) of Liberia?
Keep it short and to the point. 4.78e+05. In the year 1964, what is the difference between the Emissions(kt) of Middle income and Emissions(kt) of St. Vincent and the Grenadines?
Ensure brevity in your answer.  4.78e+05. In the year 1964, what is the difference between the Emissions(kt) in Iraq and Emissions(kt) in Liberia?
Provide a succinct answer. 6582.27. In the year 1964, what is the difference between the Emissions(kt) of Iraq and Emissions(kt) of St. Vincent and the Grenadines?
Offer a very short reply. 7047.97. In the year 1964, what is the difference between the Emissions(kt) in Liberia and Emissions(kt) in St. Vincent and the Grenadines?
Your answer should be compact. 465.71. In the year 1965, what is the difference between the Emissions(kt) of Middle income and Emissions(kt) of Iraq?
Provide a short and direct response. 5.01e+05. In the year 1965, what is the difference between the Emissions(kt) in Middle income and Emissions(kt) in Liberia?
Give a very brief answer. 5.09e+05. In the year 1965, what is the difference between the Emissions(kt) of Middle income and Emissions(kt) of St. Vincent and the Grenadines?
Ensure brevity in your answer.  5.09e+05. In the year 1965, what is the difference between the Emissions(kt) in Iraq and Emissions(kt) in Liberia?
Offer a very short reply. 7495.35. In the year 1965, what is the difference between the Emissions(kt) of Iraq and Emissions(kt) of St. Vincent and the Grenadines?
Your response must be concise. 8038.06. In the year 1965, what is the difference between the Emissions(kt) in Liberia and Emissions(kt) in St. Vincent and the Grenadines?
Your answer should be compact. 542.72. In the year 1966, what is the difference between the Emissions(kt) of Middle income and Emissions(kt) of Iraq?
Ensure brevity in your answer.  5.66e+05. In the year 1966, what is the difference between the Emissions(kt) of Middle income and Emissions(kt) of Liberia?
Offer a terse response. 5.80e+05. In the year 1966, what is the difference between the Emissions(kt) in Middle income and Emissions(kt) in St. Vincent and the Grenadines?
Your answer should be compact. 5.81e+05. In the year 1966, what is the difference between the Emissions(kt) in Iraq and Emissions(kt) in Liberia?
Offer a very short reply. 1.45e+04. In the year 1966, what is the difference between the Emissions(kt) of Iraq and Emissions(kt) of St. Vincent and the Grenadines?
Your answer should be very brief. 1.51e+04. In the year 1966, what is the difference between the Emissions(kt) of Liberia and Emissions(kt) of St. Vincent and the Grenadines?
Ensure brevity in your answer.  594.05. In the year 1967, what is the difference between the Emissions(kt) in Middle income and Emissions(kt) in Iraq?
Your response must be concise. 5.90e+05. In the year 1967, what is the difference between the Emissions(kt) in Middle income and Emissions(kt) in Liberia?
Provide a short and direct response. 5.96e+05. In the year 1967, what is the difference between the Emissions(kt) in Middle income and Emissions(kt) in St. Vincent and the Grenadines?
Make the answer very short. 5.97e+05. In the year 1967, what is the difference between the Emissions(kt) of Iraq and Emissions(kt) of Liberia?
Provide a succinct answer. 6175.23. In the year 1967, what is the difference between the Emissions(kt) in Iraq and Emissions(kt) in St. Vincent and the Grenadines?
Your response must be concise. 6769.28. In the year 1967, what is the difference between the Emissions(kt) in Liberia and Emissions(kt) in St. Vincent and the Grenadines?
Offer a terse response. 594.05. In the year 1968, what is the difference between the Emissions(kt) of Middle income and Emissions(kt) of Iraq?
Offer a very short reply. 6.82e+05. In the year 1968, what is the difference between the Emissions(kt) in Middle income and Emissions(kt) in Liberia?
Offer a very short reply. 6.91e+05. In the year 1968, what is the difference between the Emissions(kt) of Middle income and Emissions(kt) of St. Vincent and the Grenadines?
Ensure brevity in your answer.  6.92e+05. In the year 1968, what is the difference between the Emissions(kt) of Iraq and Emissions(kt) of Liberia?
Your answer should be very brief. 8485.44. In the year 1968, what is the difference between the Emissions(kt) in Iraq and Emissions(kt) in St. Vincent and the Grenadines?
Make the answer very short. 9321.51. In the year 1968, what is the difference between the Emissions(kt) of Liberia and Emissions(kt) of St. Vincent and the Grenadines?
Offer a very short reply. 836.08. In the year 1969, what is the difference between the Emissions(kt) in Middle income and Emissions(kt) in Iraq?
Give a very brief answer. 7.39e+05. In the year 1969, what is the difference between the Emissions(kt) in Middle income and Emissions(kt) in Liberia?
Your answer should be very brief. 7.47e+05. In the year 1969, what is the difference between the Emissions(kt) in Middle income and Emissions(kt) in St. Vincent and the Grenadines?
Provide a short and direct response. 7.49e+05. In the year 1969, what is the difference between the Emissions(kt) in Iraq and Emissions(kt) in Liberia?
Keep it short and to the point. 8841.14. In the year 1969, what is the difference between the Emissions(kt) in Iraq and Emissions(kt) in St. Vincent and the Grenadines?
Make the answer very short. 1.00e+04. In the year 1969, what is the difference between the Emissions(kt) in Liberia and Emissions(kt) in St. Vincent and the Grenadines?
Offer a terse response. 1206.44. In the year 1970, what is the difference between the Emissions(kt) of Middle income and Emissions(kt) of Iraq?
Keep it short and to the point. 8.34e+05. In the year 1970, what is the difference between the Emissions(kt) in Middle income and Emissions(kt) in Liberia?
Give a very brief answer. 8.44e+05. In the year 1970, what is the difference between the Emissions(kt) in Middle income and Emissions(kt) in St. Vincent and the Grenadines?
Provide a succinct answer. 8.46e+05. In the year 1970, what is the difference between the Emissions(kt) in Iraq and Emissions(kt) in Liberia?
Ensure brevity in your answer.  1.00e+04. In the year 1970, what is the difference between the Emissions(kt) in Iraq and Emissions(kt) in St. Vincent and the Grenadines?
Offer a terse response. 1.14e+04. In the year 1970, what is the difference between the Emissions(kt) of Liberia and Emissions(kt) of St. Vincent and the Grenadines?
Make the answer very short. 1378.79. What is the ratio of the Emissions(kt) of Middle income in 1963 to that in 1964?
Ensure brevity in your answer.  0.9. What is the ratio of the Emissions(kt) of Iraq in 1963 to that in 1964?
Give a very brief answer. 1.07. What is the ratio of the Emissions(kt) in Liberia in 1963 to that in 1964?
Give a very brief answer. 0.73. What is the ratio of the Emissions(kt) in Middle income in 1963 to that in 1965?
Provide a succinct answer. 0.85. What is the ratio of the Emissions(kt) of Iraq in 1963 to that in 1965?
Offer a terse response. 0.93. What is the ratio of the Emissions(kt) of Liberia in 1963 to that in 1965?
Your response must be concise. 0.64. What is the ratio of the Emissions(kt) in Middle income in 1963 to that in 1966?
Your answer should be compact. 0.74. What is the ratio of the Emissions(kt) in Iraq in 1963 to that in 1966?
Ensure brevity in your answer.  0.5. What is the ratio of the Emissions(kt) in Liberia in 1963 to that in 1966?
Give a very brief answer. 0.58. What is the ratio of the Emissions(kt) of Middle income in 1963 to that in 1967?
Provide a succinct answer. 0.72. What is the ratio of the Emissions(kt) of Iraq in 1963 to that in 1967?
Offer a terse response. 1.11. What is the ratio of the Emissions(kt) of Liberia in 1963 to that in 1967?
Ensure brevity in your answer.  0.58. What is the ratio of the Emissions(kt) in Middle income in 1963 to that in 1968?
Your answer should be very brief. 0.62. What is the ratio of the Emissions(kt) of Iraq in 1963 to that in 1968?
Your response must be concise. 0.81. What is the ratio of the Emissions(kt) in Liberia in 1963 to that in 1968?
Offer a very short reply. 0.41. What is the ratio of the Emissions(kt) of St. Vincent and the Grenadines in 1963 to that in 1968?
Offer a very short reply. 0.67. What is the ratio of the Emissions(kt) in Middle income in 1963 to that in 1969?
Make the answer very short. 0.58. What is the ratio of the Emissions(kt) of Iraq in 1963 to that in 1969?
Keep it short and to the point. 0.75. What is the ratio of the Emissions(kt) in Liberia in 1963 to that in 1969?
Give a very brief answer. 0.29. What is the ratio of the Emissions(kt) of St. Vincent and the Grenadines in 1963 to that in 1969?
Provide a short and direct response. 0.5. What is the ratio of the Emissions(kt) in Middle income in 1963 to that in 1970?
Give a very brief answer. 0.51. What is the ratio of the Emissions(kt) of Iraq in 1963 to that in 1970?
Offer a terse response. 0.66. What is the ratio of the Emissions(kt) of Liberia in 1963 to that in 1970?
Make the answer very short. 0.25. What is the ratio of the Emissions(kt) in St. Vincent and the Grenadines in 1963 to that in 1970?
Your answer should be very brief. 0.5. What is the ratio of the Emissions(kt) of Middle income in 1964 to that in 1965?
Give a very brief answer. 0.94. What is the ratio of the Emissions(kt) of Iraq in 1964 to that in 1965?
Offer a very short reply. 0.88. What is the ratio of the Emissions(kt) of Liberia in 1964 to that in 1965?
Offer a terse response. 0.87. What is the ratio of the Emissions(kt) in Middle income in 1964 to that in 1966?
Your answer should be compact. 0.82. What is the ratio of the Emissions(kt) in Iraq in 1964 to that in 1966?
Keep it short and to the point. 0.47. What is the ratio of the Emissions(kt) in Liberia in 1964 to that in 1966?
Offer a very short reply. 0.79. What is the ratio of the Emissions(kt) in Middle income in 1964 to that in 1967?
Your answer should be compact. 0.8. What is the ratio of the Emissions(kt) of Iraq in 1964 to that in 1967?
Your answer should be very brief. 1.04. What is the ratio of the Emissions(kt) of Liberia in 1964 to that in 1967?
Ensure brevity in your answer.  0.79. What is the ratio of the Emissions(kt) of St. Vincent and the Grenadines in 1964 to that in 1967?
Give a very brief answer. 1. What is the ratio of the Emissions(kt) of Middle income in 1964 to that in 1968?
Ensure brevity in your answer.  0.69. What is the ratio of the Emissions(kt) of Iraq in 1964 to that in 1968?
Provide a succinct answer. 0.76. What is the ratio of the Emissions(kt) of Liberia in 1964 to that in 1968?
Provide a short and direct response. 0.56. What is the ratio of the Emissions(kt) of St. Vincent and the Grenadines in 1964 to that in 1968?
Make the answer very short. 0.83. What is the ratio of the Emissions(kt) of Middle income in 1964 to that in 1969?
Your response must be concise. 0.64. What is the ratio of the Emissions(kt) of Iraq in 1964 to that in 1969?
Provide a succinct answer. 0.7. What is the ratio of the Emissions(kt) in Liberia in 1964 to that in 1969?
Make the answer very short. 0.39. What is the ratio of the Emissions(kt) in St. Vincent and the Grenadines in 1964 to that in 1969?
Your response must be concise. 0.62. What is the ratio of the Emissions(kt) in Middle income in 1964 to that in 1970?
Provide a succinct answer. 0.57. What is the ratio of the Emissions(kt) in Iraq in 1964 to that in 1970?
Ensure brevity in your answer.  0.62. What is the ratio of the Emissions(kt) of Liberia in 1964 to that in 1970?
Your answer should be compact. 0.34. What is the ratio of the Emissions(kt) of Middle income in 1965 to that in 1966?
Give a very brief answer. 0.88. What is the ratio of the Emissions(kt) of Iraq in 1965 to that in 1966?
Offer a terse response. 0.53. What is the ratio of the Emissions(kt) in Liberia in 1965 to that in 1966?
Your response must be concise. 0.91. What is the ratio of the Emissions(kt) in St. Vincent and the Grenadines in 1965 to that in 1966?
Provide a succinct answer. 0.8. What is the ratio of the Emissions(kt) of Middle income in 1965 to that in 1967?
Provide a short and direct response. 0.85. What is the ratio of the Emissions(kt) in Iraq in 1965 to that in 1967?
Provide a succinct answer. 1.19. What is the ratio of the Emissions(kt) in Liberia in 1965 to that in 1967?
Your answer should be compact. 0.91. What is the ratio of the Emissions(kt) of St. Vincent and the Grenadines in 1965 to that in 1967?
Keep it short and to the point. 0.8. What is the ratio of the Emissions(kt) in Middle income in 1965 to that in 1968?
Make the answer very short. 0.74. What is the ratio of the Emissions(kt) in Iraq in 1965 to that in 1968?
Give a very brief answer. 0.86. What is the ratio of the Emissions(kt) of Liberia in 1965 to that in 1968?
Give a very brief answer. 0.65. What is the ratio of the Emissions(kt) in St. Vincent and the Grenadines in 1965 to that in 1968?
Make the answer very short. 0.67. What is the ratio of the Emissions(kt) of Middle income in 1965 to that in 1969?
Provide a succinct answer. 0.68. What is the ratio of the Emissions(kt) of Iraq in 1965 to that in 1969?
Keep it short and to the point. 0.8. What is the ratio of the Emissions(kt) in Liberia in 1965 to that in 1969?
Provide a succinct answer. 0.45. What is the ratio of the Emissions(kt) in St. Vincent and the Grenadines in 1965 to that in 1969?
Provide a succinct answer. 0.5. What is the ratio of the Emissions(kt) in Middle income in 1965 to that in 1970?
Offer a terse response. 0.6. What is the ratio of the Emissions(kt) of Iraq in 1965 to that in 1970?
Give a very brief answer. 0.7. What is the ratio of the Emissions(kt) of Liberia in 1965 to that in 1970?
Offer a very short reply. 0.4. What is the ratio of the Emissions(kt) in St. Vincent and the Grenadines in 1965 to that in 1970?
Keep it short and to the point. 0.5. What is the ratio of the Emissions(kt) in Middle income in 1966 to that in 1967?
Keep it short and to the point. 0.97. What is the ratio of the Emissions(kt) of Iraq in 1966 to that in 1967?
Make the answer very short. 2.23. What is the ratio of the Emissions(kt) of Liberia in 1966 to that in 1967?
Give a very brief answer. 1. What is the ratio of the Emissions(kt) in Middle income in 1966 to that in 1968?
Your answer should be compact. 0.84. What is the ratio of the Emissions(kt) of Iraq in 1966 to that in 1968?
Your answer should be very brief. 1.62. What is the ratio of the Emissions(kt) in Liberia in 1966 to that in 1968?
Provide a short and direct response. 0.71. What is the ratio of the Emissions(kt) of Middle income in 1966 to that in 1969?
Ensure brevity in your answer.  0.78. What is the ratio of the Emissions(kt) of Iraq in 1966 to that in 1969?
Your response must be concise. 1.5. What is the ratio of the Emissions(kt) of Liberia in 1966 to that in 1969?
Make the answer very short. 0.5. What is the ratio of the Emissions(kt) in Middle income in 1966 to that in 1970?
Keep it short and to the point. 0.69. What is the ratio of the Emissions(kt) in Iraq in 1966 to that in 1970?
Ensure brevity in your answer.  1.32. What is the ratio of the Emissions(kt) of Liberia in 1966 to that in 1970?
Offer a very short reply. 0.43. What is the ratio of the Emissions(kt) of St. Vincent and the Grenadines in 1966 to that in 1970?
Ensure brevity in your answer.  0.62. What is the ratio of the Emissions(kt) of Middle income in 1967 to that in 1968?
Give a very brief answer. 0.86. What is the ratio of the Emissions(kt) in Iraq in 1967 to that in 1968?
Your answer should be compact. 0.73. What is the ratio of the Emissions(kt) of Liberia in 1967 to that in 1968?
Offer a terse response. 0.71. What is the ratio of the Emissions(kt) in Middle income in 1967 to that in 1969?
Provide a succinct answer. 0.8. What is the ratio of the Emissions(kt) in Iraq in 1967 to that in 1969?
Provide a short and direct response. 0.67. What is the ratio of the Emissions(kt) of Liberia in 1967 to that in 1969?
Your answer should be very brief. 0.5. What is the ratio of the Emissions(kt) of St. Vincent and the Grenadines in 1967 to that in 1969?
Provide a short and direct response. 0.62. What is the ratio of the Emissions(kt) of Middle income in 1967 to that in 1970?
Give a very brief answer. 0.71. What is the ratio of the Emissions(kt) in Iraq in 1967 to that in 1970?
Make the answer very short. 0.59. What is the ratio of the Emissions(kt) in Liberia in 1967 to that in 1970?
Ensure brevity in your answer.  0.43. What is the ratio of the Emissions(kt) of Middle income in 1968 to that in 1969?
Provide a succinct answer. 0.92. What is the ratio of the Emissions(kt) of Iraq in 1968 to that in 1969?
Give a very brief answer. 0.93. What is the ratio of the Emissions(kt) in Liberia in 1968 to that in 1969?
Provide a succinct answer. 0.69. What is the ratio of the Emissions(kt) of Middle income in 1968 to that in 1970?
Provide a succinct answer. 0.82. What is the ratio of the Emissions(kt) of Iraq in 1968 to that in 1970?
Your response must be concise. 0.82. What is the ratio of the Emissions(kt) of Liberia in 1968 to that in 1970?
Your response must be concise. 0.61. What is the ratio of the Emissions(kt) in St. Vincent and the Grenadines in 1968 to that in 1970?
Ensure brevity in your answer.  0.75. What is the ratio of the Emissions(kt) of Middle income in 1969 to that in 1970?
Offer a very short reply. 0.89. What is the ratio of the Emissions(kt) in Iraq in 1969 to that in 1970?
Offer a terse response. 0.88. What is the ratio of the Emissions(kt) in Liberia in 1969 to that in 1970?
Make the answer very short. 0.88. What is the ratio of the Emissions(kt) of St. Vincent and the Grenadines in 1969 to that in 1970?
Keep it short and to the point. 1. What is the difference between the highest and the second highest Emissions(kt) in Middle income?
Your response must be concise. 9.70e+04. What is the difference between the highest and the second highest Emissions(kt) in Iraq?
Offer a terse response. 3685.34. What is the difference between the highest and the second highest Emissions(kt) of Liberia?
Ensure brevity in your answer.  172.35. What is the difference between the highest and the lowest Emissions(kt) in Middle income?
Give a very brief answer. 4.13e+05. What is the difference between the highest and the lowest Emissions(kt) in Iraq?
Provide a succinct answer. 8324.09. What is the difference between the highest and the lowest Emissions(kt) in Liberia?
Provide a short and direct response. 1052.43. What is the difference between the highest and the lowest Emissions(kt) in St. Vincent and the Grenadines?
Your answer should be compact. 14.67. 